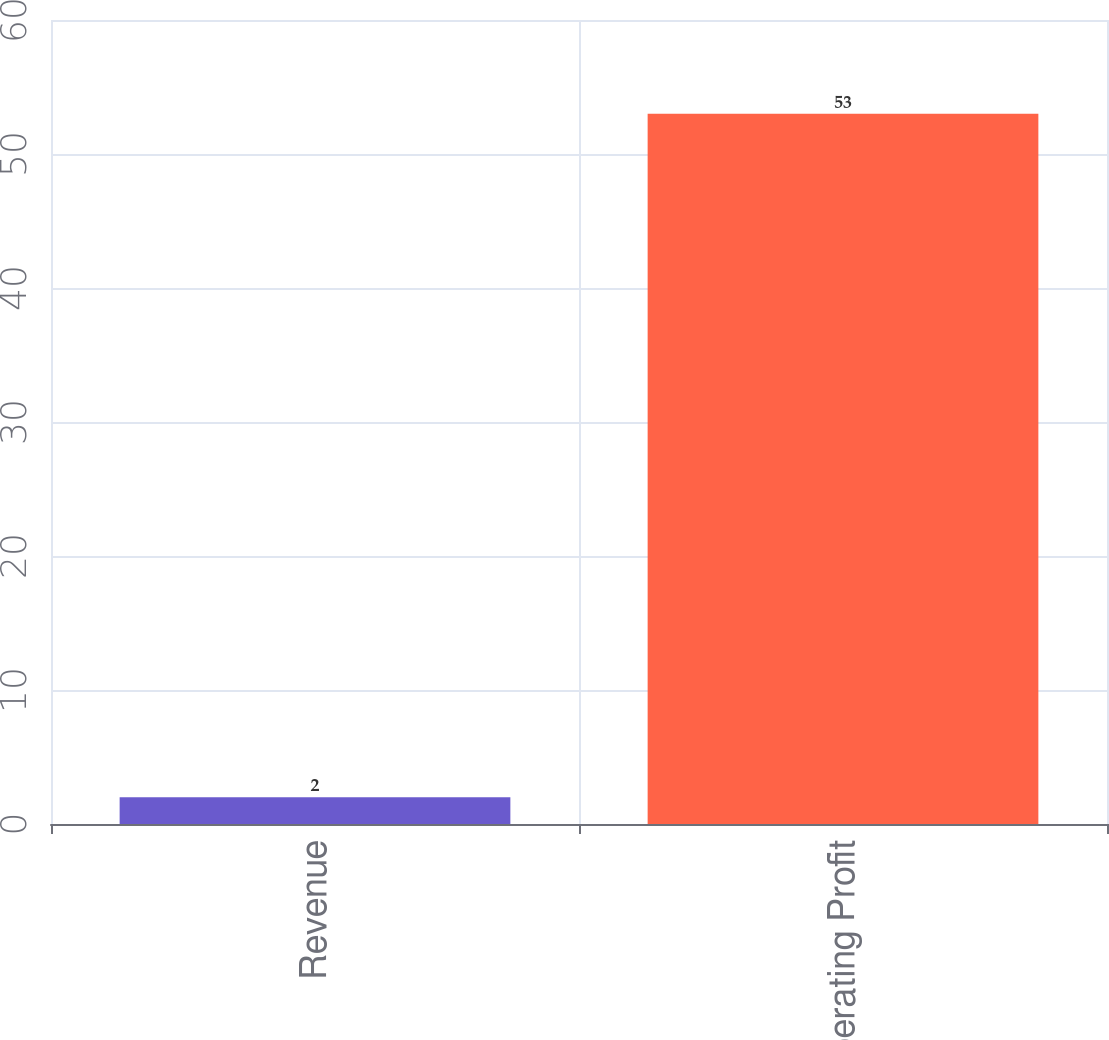Convert chart. <chart><loc_0><loc_0><loc_500><loc_500><bar_chart><fcel>Revenue<fcel>Operating Profit<nl><fcel>2<fcel>53<nl></chart> 